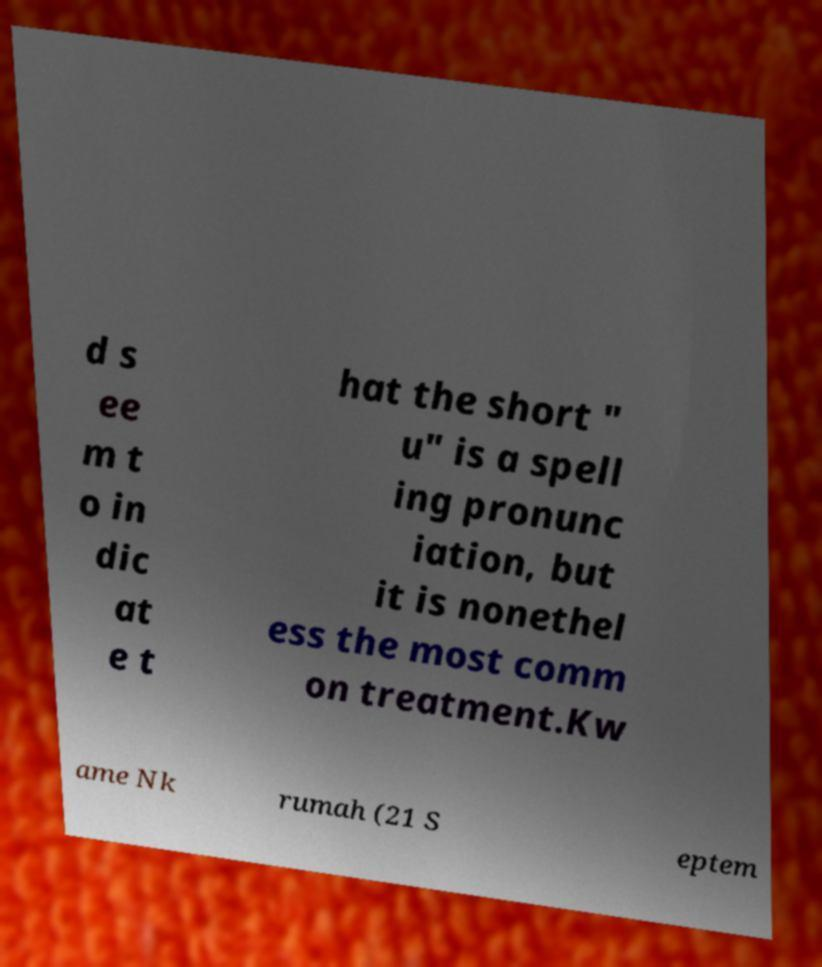Can you read and provide the text displayed in the image?This photo seems to have some interesting text. Can you extract and type it out for me? d s ee m t o in dic at e t hat the short " u" is a spell ing pronunc iation, but it is nonethel ess the most comm on treatment.Kw ame Nk rumah (21 S eptem 